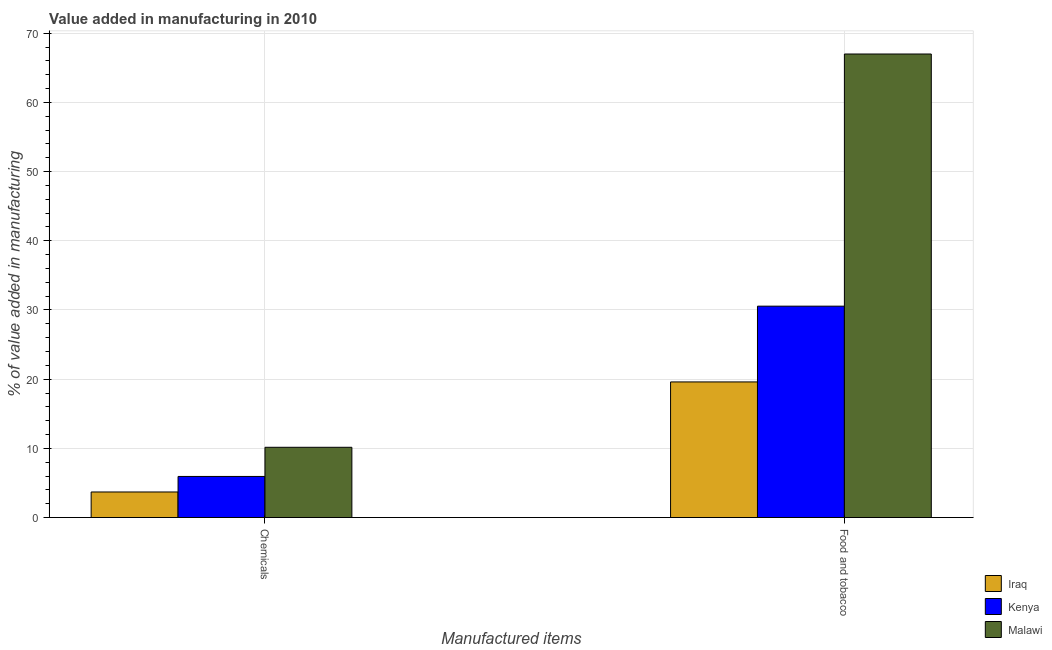How many different coloured bars are there?
Keep it short and to the point. 3. How many bars are there on the 1st tick from the right?
Provide a succinct answer. 3. What is the label of the 1st group of bars from the left?
Provide a short and direct response. Chemicals. What is the value added by manufacturing food and tobacco in Iraq?
Your response must be concise. 19.6. Across all countries, what is the maximum value added by  manufacturing chemicals?
Keep it short and to the point. 10.16. Across all countries, what is the minimum value added by  manufacturing chemicals?
Your answer should be very brief. 3.7. In which country was the value added by  manufacturing chemicals maximum?
Your answer should be very brief. Malawi. In which country was the value added by manufacturing food and tobacco minimum?
Offer a very short reply. Iraq. What is the total value added by manufacturing food and tobacco in the graph?
Your answer should be very brief. 117.14. What is the difference between the value added by manufacturing food and tobacco in Kenya and that in Malawi?
Make the answer very short. -36.44. What is the difference between the value added by  manufacturing chemicals in Kenya and the value added by manufacturing food and tobacco in Iraq?
Your response must be concise. -13.66. What is the average value added by manufacturing food and tobacco per country?
Keep it short and to the point. 39.05. What is the difference between the value added by  manufacturing chemicals and value added by manufacturing food and tobacco in Malawi?
Make the answer very short. -56.83. In how many countries, is the value added by manufacturing food and tobacco greater than 66 %?
Provide a short and direct response. 1. What is the ratio of the value added by manufacturing food and tobacco in Iraq to that in Kenya?
Provide a succinct answer. 0.64. Is the value added by manufacturing food and tobacco in Malawi less than that in Kenya?
Offer a terse response. No. What does the 3rd bar from the left in Food and tobacco represents?
Your answer should be very brief. Malawi. What does the 1st bar from the right in Chemicals represents?
Your answer should be compact. Malawi. Are the values on the major ticks of Y-axis written in scientific E-notation?
Provide a short and direct response. No. Where does the legend appear in the graph?
Keep it short and to the point. Bottom right. How are the legend labels stacked?
Make the answer very short. Vertical. What is the title of the graph?
Provide a succinct answer. Value added in manufacturing in 2010. What is the label or title of the X-axis?
Keep it short and to the point. Manufactured items. What is the label or title of the Y-axis?
Ensure brevity in your answer.  % of value added in manufacturing. What is the % of value added in manufacturing in Iraq in Chemicals?
Make the answer very short. 3.7. What is the % of value added in manufacturing of Kenya in Chemicals?
Give a very brief answer. 5.94. What is the % of value added in manufacturing in Malawi in Chemicals?
Your answer should be compact. 10.16. What is the % of value added in manufacturing in Iraq in Food and tobacco?
Provide a short and direct response. 19.6. What is the % of value added in manufacturing in Kenya in Food and tobacco?
Ensure brevity in your answer.  30.55. What is the % of value added in manufacturing of Malawi in Food and tobacco?
Provide a short and direct response. 66.99. Across all Manufactured items, what is the maximum % of value added in manufacturing of Iraq?
Offer a terse response. 19.6. Across all Manufactured items, what is the maximum % of value added in manufacturing of Kenya?
Offer a terse response. 30.55. Across all Manufactured items, what is the maximum % of value added in manufacturing of Malawi?
Your answer should be compact. 66.99. Across all Manufactured items, what is the minimum % of value added in manufacturing of Iraq?
Make the answer very short. 3.7. Across all Manufactured items, what is the minimum % of value added in manufacturing in Kenya?
Your response must be concise. 5.94. Across all Manufactured items, what is the minimum % of value added in manufacturing in Malawi?
Ensure brevity in your answer.  10.16. What is the total % of value added in manufacturing in Iraq in the graph?
Provide a succinct answer. 23.3. What is the total % of value added in manufacturing in Kenya in the graph?
Provide a succinct answer. 36.49. What is the total % of value added in manufacturing in Malawi in the graph?
Make the answer very short. 77.14. What is the difference between the % of value added in manufacturing of Iraq in Chemicals and that in Food and tobacco?
Provide a short and direct response. -15.9. What is the difference between the % of value added in manufacturing of Kenya in Chemicals and that in Food and tobacco?
Ensure brevity in your answer.  -24.61. What is the difference between the % of value added in manufacturing of Malawi in Chemicals and that in Food and tobacco?
Your answer should be very brief. -56.83. What is the difference between the % of value added in manufacturing in Iraq in Chemicals and the % of value added in manufacturing in Kenya in Food and tobacco?
Keep it short and to the point. -26.85. What is the difference between the % of value added in manufacturing in Iraq in Chemicals and the % of value added in manufacturing in Malawi in Food and tobacco?
Your answer should be very brief. -63.29. What is the difference between the % of value added in manufacturing of Kenya in Chemicals and the % of value added in manufacturing of Malawi in Food and tobacco?
Offer a very short reply. -61.05. What is the average % of value added in manufacturing in Iraq per Manufactured items?
Ensure brevity in your answer.  11.65. What is the average % of value added in manufacturing in Kenya per Manufactured items?
Offer a very short reply. 18.24. What is the average % of value added in manufacturing in Malawi per Manufactured items?
Provide a short and direct response. 38.57. What is the difference between the % of value added in manufacturing in Iraq and % of value added in manufacturing in Kenya in Chemicals?
Offer a terse response. -2.24. What is the difference between the % of value added in manufacturing of Iraq and % of value added in manufacturing of Malawi in Chemicals?
Your response must be concise. -6.46. What is the difference between the % of value added in manufacturing of Kenya and % of value added in manufacturing of Malawi in Chemicals?
Ensure brevity in your answer.  -4.22. What is the difference between the % of value added in manufacturing in Iraq and % of value added in manufacturing in Kenya in Food and tobacco?
Offer a terse response. -10.95. What is the difference between the % of value added in manufacturing of Iraq and % of value added in manufacturing of Malawi in Food and tobacco?
Provide a short and direct response. -47.39. What is the difference between the % of value added in manufacturing of Kenya and % of value added in manufacturing of Malawi in Food and tobacco?
Offer a very short reply. -36.44. What is the ratio of the % of value added in manufacturing of Iraq in Chemicals to that in Food and tobacco?
Provide a succinct answer. 0.19. What is the ratio of the % of value added in manufacturing of Kenya in Chemicals to that in Food and tobacco?
Offer a terse response. 0.19. What is the ratio of the % of value added in manufacturing of Malawi in Chemicals to that in Food and tobacco?
Make the answer very short. 0.15. What is the difference between the highest and the second highest % of value added in manufacturing in Iraq?
Your response must be concise. 15.9. What is the difference between the highest and the second highest % of value added in manufacturing in Kenya?
Make the answer very short. 24.61. What is the difference between the highest and the second highest % of value added in manufacturing in Malawi?
Give a very brief answer. 56.83. What is the difference between the highest and the lowest % of value added in manufacturing in Iraq?
Make the answer very short. 15.9. What is the difference between the highest and the lowest % of value added in manufacturing of Kenya?
Your response must be concise. 24.61. What is the difference between the highest and the lowest % of value added in manufacturing of Malawi?
Ensure brevity in your answer.  56.83. 